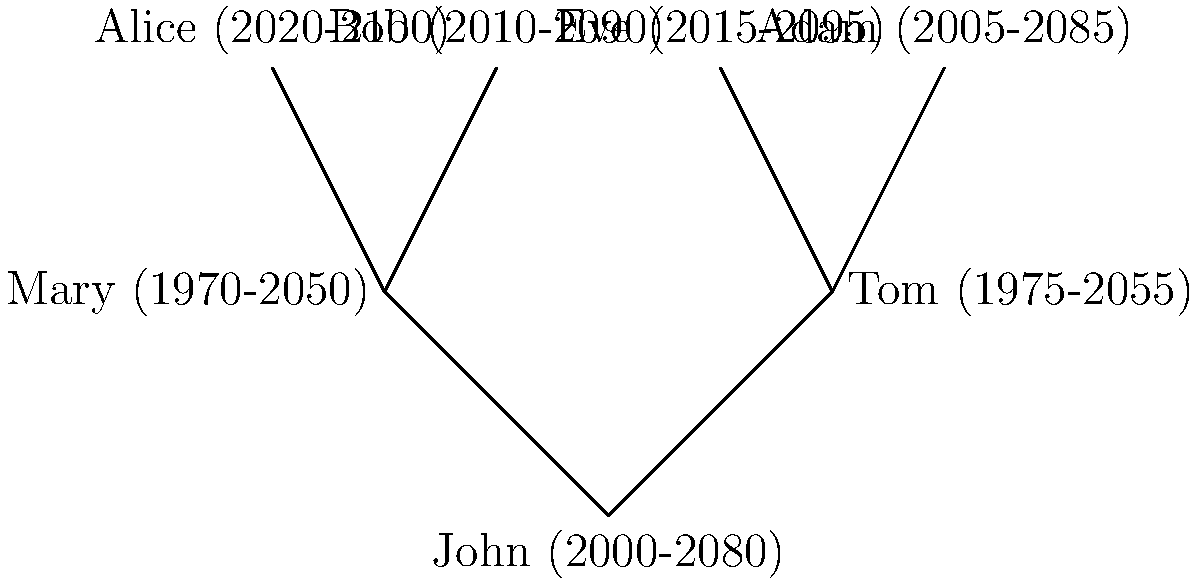In this family tree diagram, there appears to be a temporal anomaly. Which individual's birth year contradicts the expected chronological order of generations? To identify the temporal anomaly in this family tree, we need to analyze the birth years of each generation:

1. First generation (parents):
   - Mary: born in 1970
   - Tom: born in 1975

2. Second generation (children):
   - John: born in 2000
   - Adam: born in 2005
   - Bob: born in 2010
   - Eve: born in 2015
   - Alice: born in 2020

3. Normally, we would expect parents to be born before their children.

4. John, who is positioned as a child of Mary and Tom, was born in 2000.

5. However, John's supposed parents, Mary and Tom, were born in 1970 and 1975 respectively.

6. This means John was born only 25-30 years after his parents, which is possible but unusually early.

7. More importantly, John's children (Alice, Bob, Eve, and Adam) were born between 2005 and 2020, making some of them older than their supposed father.

Therefore, John's birth year (2000) contradicts the expected chronological order of generations, as he appears to be from the same generation as his supposed children rather than being their parent.
Answer: John (2000) 